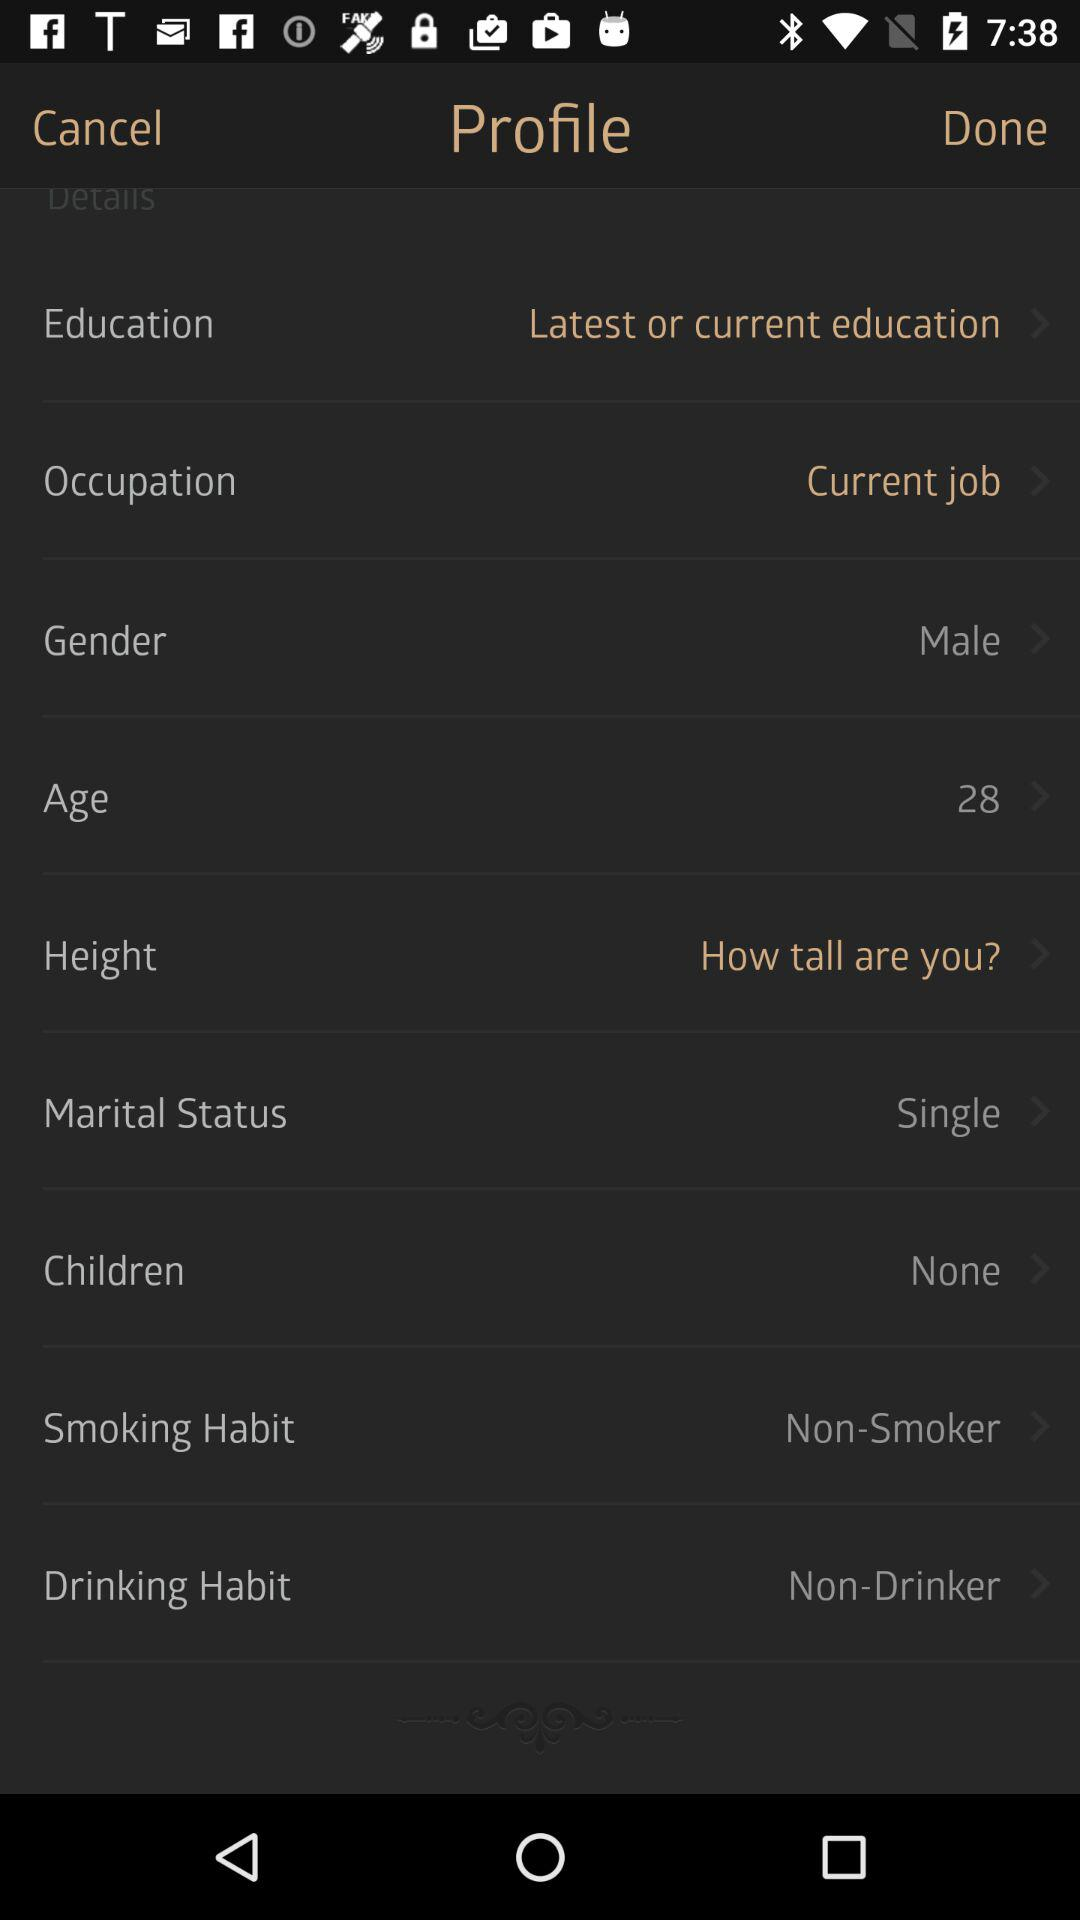What's the marital status? The marital status is single. 